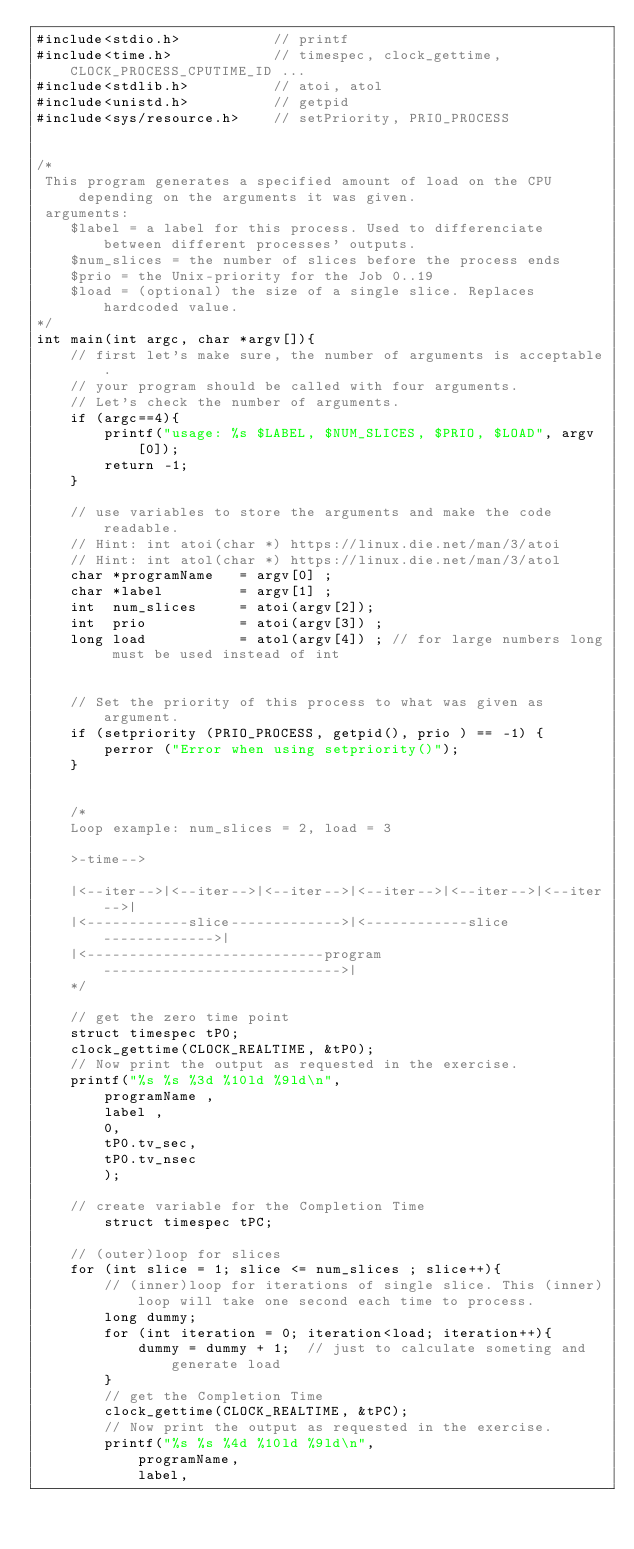Convert code to text. <code><loc_0><loc_0><loc_500><loc_500><_C_>#include<stdio.h> 			// printf
#include<time.h> 			// timespec, clock_gettime, CLOCK_PROCESS_CPUTIME_ID ...
#include<stdlib.h> 			// atoi, atol
#include<unistd.h> 			// getpid
#include<sys/resource.h> 	// setPriority, PRIO_PROCESS


/*
 This program generates a specified amount of load on the CPU depending on the arguments it was given.
 arguments:
	$label = a label for this process. Used to differenciate between different processes' outputs.
	$num_slices = the number of slices before the process ends
	$prio = the Unix-priority for the Job 0..19
	$load = (optional) the size of a single slice. Replaces hardcoded value.
*/
int main(int argc, char *argv[]){
	// first let's make sure, the number of arguments is acceptable.
	// your program should be called with four arguments.
	// Let's check the number of arguments. 
	if (argc==4){
       	printf("usage: %s $LABEL, $NUM_SLICES, $PRIO, $LOAD", argv[0]);
		return -1;
	}
	
	// use variables to store the arguments and make the code readable. 
	// Hint: int atoi(char *) https://linux.die.net/man/3/atoi
	// Hint: int atol(char *) https://linux.die.net/man/3/atol
	char *programName 	= argv[0] ;
	char *label 		= argv[1] ;
	int  num_slices 	= atoi(argv[2]);
	int  prio 			= atoi(argv[3]) ;
	long load 			= atol(argv[4]) ; // for large numbers long must be used instead of int
	
	
	// Set the priority of this process to what was given as argument. 
	if (setpriority (PRIO_PROCESS, getpid(), prio ) == -1) {
        perror ("Error when using setpriority()");
    }
	
	
	/*
	Loop example: num_slices = 2, load = 3
	
	>-time-->
	
	|<--iter-->|<--iter-->|<--iter-->|<--iter-->|<--iter-->|<--iter-->|
	|<------------slice------------->|<------------slice------------->|
	|<----------------------------program---------------------------->|
	*/
	
	// get the zero time point
	struct timespec tP0;
	clock_gettime(CLOCK_REALTIME, &tP0);
	// Now print the output as requested in the exercise.
	printf("%s %s %3d %10ld %9ld\n",
		programName ,
		label ,
		0,
		tP0.tv_sec,
		tP0.tv_nsec
		);

	// create variable for the Completion Time
		struct timespec tPC;

	// (outer)loop for slices
	for (int slice = 1; slice <= num_slices ; slice++){
		// (inner)loop for iterations of single slice. This (inner)loop will take one second each time to process.
		long dummy;
		for (int iteration = 0; iteration<load; iteration++){
			dummy = dummy + 1;  // just to calculate someting and generate load
		}
		// get the Completion Time
		clock_gettime(CLOCK_REALTIME, &tPC);
		// Now print the output as requested in the exercise.
		printf("%s %s %4d %10ld %9ld\n",
            programName,
			label,</code> 